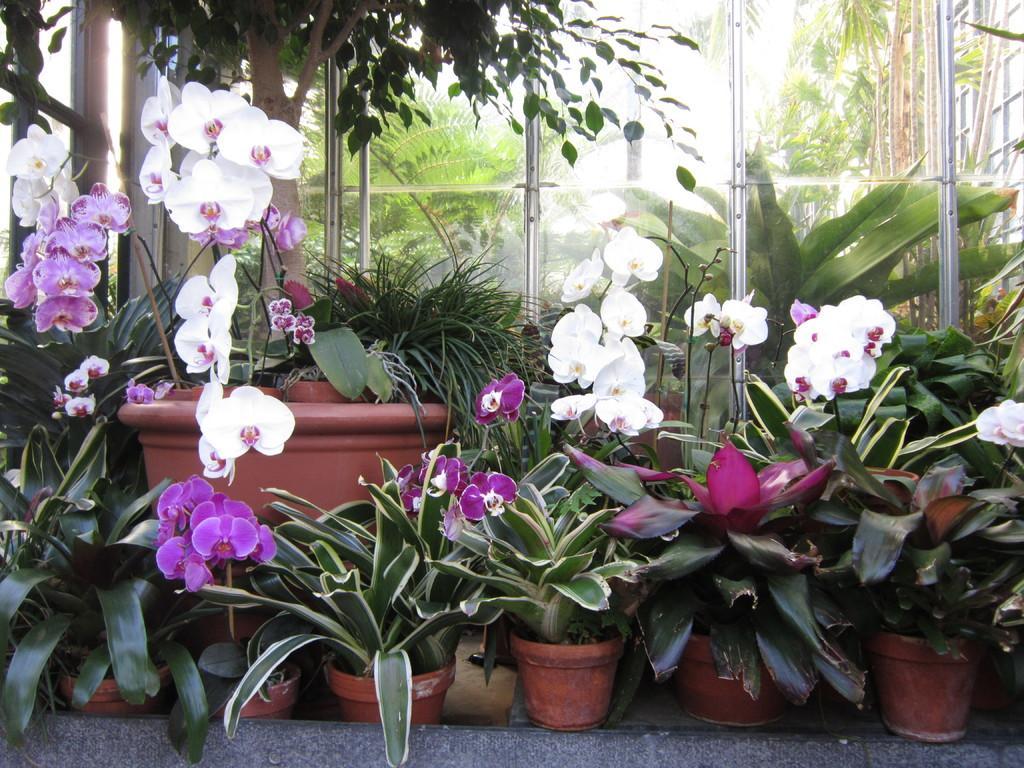Please provide a concise description of this image. In the foreground of the picture there are plants, flower pots and flowers. In the center there is a glass door. 